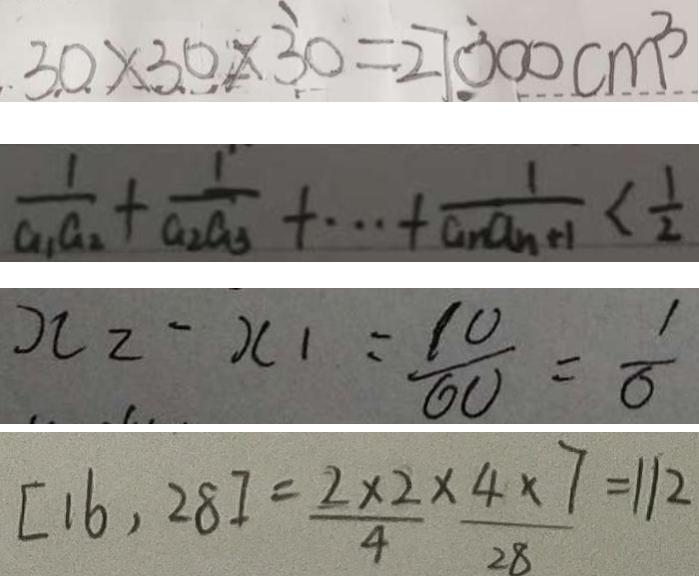Convert formula to latex. <formula><loc_0><loc_0><loc_500><loc_500>3 0 \times 3 0 \times 3 0 = 2 7 0 0 0 c m ^ { 3 } 
 \frac { 1 } { a _ { 1 } a _ { 2 } } + \frac { 1 } { a _ { 2 } a _ { 3 } } + \cdots + \frac { 1 } { a _ { n } a _ { n + 1 } } < \frac { 1 } { 2 } 
 x _ { 2 } - x _ { 1 } = \frac { 1 0 } { 6 0 } = \frac { 1 } { 6 } 
 [ 1 6 , 2 8 ] = \frac { 2 \times 2 } { 4 } \times \frac { 4 \times 7 } { 2 8 } = 1 1 2</formula> 